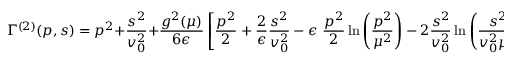<formula> <loc_0><loc_0><loc_500><loc_500>\Gamma ^ { ( 2 ) } ( p , s ) = p ^ { 2 } + \frac { s ^ { 2 } } { v _ { 0 } ^ { 2 } } + \frac { g ^ { 2 } ( \mu ) } { 6 \epsilon } \left [ \frac { p ^ { 2 } } { 2 } + \frac { 2 } { \epsilon } \frac { s ^ { 2 } } { v _ { 0 } ^ { 2 } } - \epsilon \frac { p ^ { 2 } } { 2 } \ln \left ( \frac { p ^ { 2 } } { \mu ^ { 2 } } \right ) - 2 \frac { s ^ { 2 } } { v _ { 0 } ^ { 2 } } \ln \left ( \frac { s ^ { 2 } } { v _ { 0 } ^ { 2 } \mu ^ { 2 } } \right ) \right ] + \mathcal { O } ( g ^ { 2 } \epsilon ^ { 0 } , g ^ { 2 } \epsilon , g ^ { 3 } )</formula> 